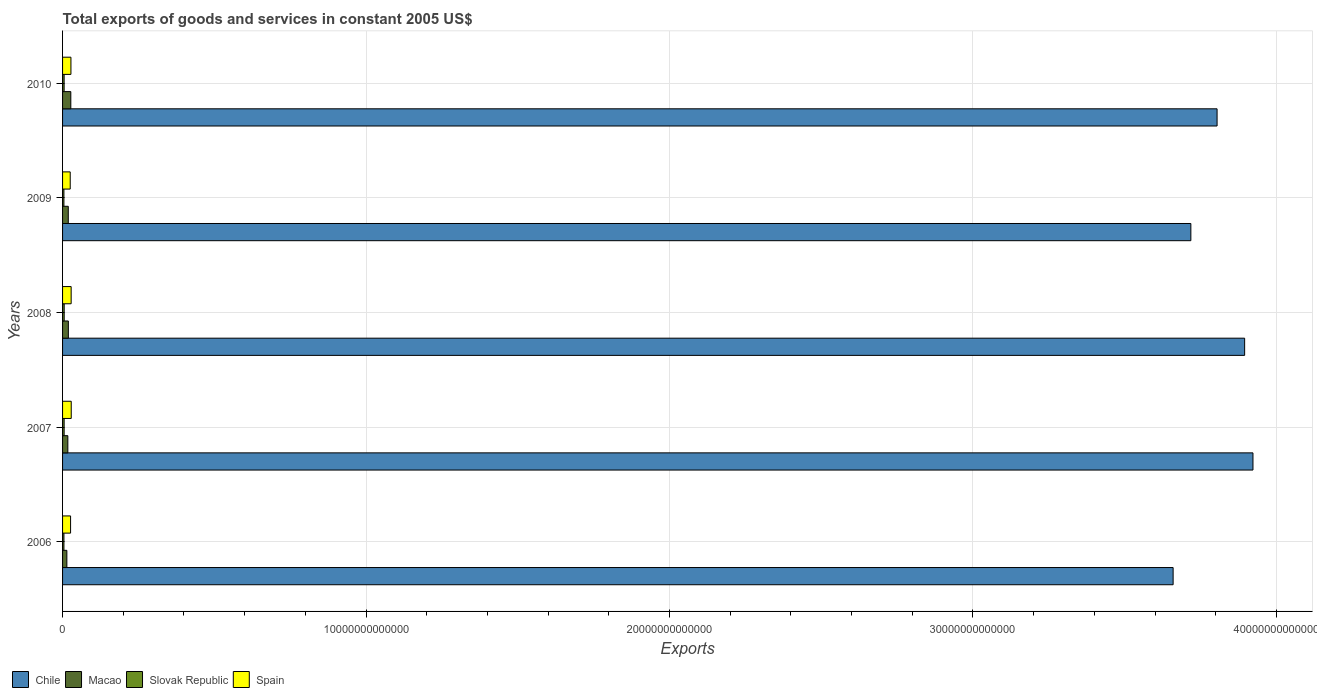How many different coloured bars are there?
Your answer should be very brief. 4. How many groups of bars are there?
Your answer should be very brief. 5. Are the number of bars on each tick of the Y-axis equal?
Give a very brief answer. Yes. What is the total exports of goods and services in Slovak Republic in 2010?
Provide a short and direct response. 5.16e+1. Across all years, what is the maximum total exports of goods and services in Spain?
Provide a short and direct response. 2.86e+11. Across all years, what is the minimum total exports of goods and services in Slovak Republic?
Provide a succinct answer. 4.46e+1. In which year was the total exports of goods and services in Chile maximum?
Offer a very short reply. 2007. What is the total total exports of goods and services in Macao in the graph?
Your answer should be compact. 9.66e+11. What is the difference between the total exports of goods and services in Chile in 2007 and that in 2010?
Keep it short and to the point. 1.18e+12. What is the difference between the total exports of goods and services in Spain in 2010 and the total exports of goods and services in Chile in 2009?
Offer a very short reply. -3.69e+13. What is the average total exports of goods and services in Macao per year?
Your answer should be compact. 1.93e+11. In the year 2010, what is the difference between the total exports of goods and services in Chile and total exports of goods and services in Macao?
Your answer should be compact. 3.78e+13. What is the ratio of the total exports of goods and services in Spain in 2008 to that in 2010?
Ensure brevity in your answer.  1.03. Is the total exports of goods and services in Chile in 2008 less than that in 2009?
Your answer should be compact. No. Is the difference between the total exports of goods and services in Chile in 2009 and 2010 greater than the difference between the total exports of goods and services in Macao in 2009 and 2010?
Your response must be concise. No. What is the difference between the highest and the second highest total exports of goods and services in Spain?
Provide a short and direct response. 2.42e+09. What is the difference between the highest and the lowest total exports of goods and services in Spain?
Your answer should be very brief. 3.37e+1. Is the sum of the total exports of goods and services in Chile in 2006 and 2008 greater than the maximum total exports of goods and services in Spain across all years?
Your answer should be compact. Yes. Is it the case that in every year, the sum of the total exports of goods and services in Chile and total exports of goods and services in Slovak Republic is greater than the sum of total exports of goods and services in Macao and total exports of goods and services in Spain?
Ensure brevity in your answer.  Yes. What does the 2nd bar from the top in 2006 represents?
Ensure brevity in your answer.  Slovak Republic. What does the 4th bar from the bottom in 2009 represents?
Give a very brief answer. Spain. Are all the bars in the graph horizontal?
Provide a succinct answer. Yes. How many years are there in the graph?
Provide a succinct answer. 5. What is the difference between two consecutive major ticks on the X-axis?
Provide a short and direct response. 1.00e+13. Does the graph contain any zero values?
Provide a succinct answer. No. How are the legend labels stacked?
Your answer should be very brief. Horizontal. What is the title of the graph?
Ensure brevity in your answer.  Total exports of goods and services in constant 2005 US$. What is the label or title of the X-axis?
Keep it short and to the point. Exports. What is the label or title of the Y-axis?
Offer a very short reply. Years. What is the Exports of Chile in 2006?
Offer a very short reply. 3.66e+13. What is the Exports of Macao in 2006?
Ensure brevity in your answer.  1.41e+11. What is the Exports of Slovak Republic in 2006?
Your answer should be compact. 4.54e+1. What is the Exports of Spain in 2006?
Your answer should be very brief. 2.64e+11. What is the Exports of Chile in 2007?
Provide a short and direct response. 3.92e+13. What is the Exports of Macao in 2007?
Provide a succinct answer. 1.74e+11. What is the Exports in Slovak Republic in 2007?
Your answer should be compact. 5.20e+1. What is the Exports in Spain in 2007?
Your answer should be compact. 2.86e+11. What is the Exports of Chile in 2008?
Your response must be concise. 3.90e+13. What is the Exports of Macao in 2008?
Offer a very short reply. 1.91e+11. What is the Exports of Slovak Republic in 2008?
Ensure brevity in your answer.  5.35e+1. What is the Exports in Spain in 2008?
Your answer should be very brief. 2.83e+11. What is the Exports of Chile in 2009?
Make the answer very short. 3.72e+13. What is the Exports of Macao in 2009?
Your answer should be compact. 1.88e+11. What is the Exports in Slovak Republic in 2009?
Provide a short and direct response. 4.46e+1. What is the Exports of Spain in 2009?
Keep it short and to the point. 2.52e+11. What is the Exports in Chile in 2010?
Give a very brief answer. 3.80e+13. What is the Exports of Macao in 2010?
Offer a terse response. 2.72e+11. What is the Exports of Slovak Republic in 2010?
Your answer should be very brief. 5.16e+1. What is the Exports in Spain in 2010?
Your answer should be very brief. 2.76e+11. Across all years, what is the maximum Exports in Chile?
Ensure brevity in your answer.  3.92e+13. Across all years, what is the maximum Exports in Macao?
Offer a very short reply. 2.72e+11. Across all years, what is the maximum Exports of Slovak Republic?
Provide a succinct answer. 5.35e+1. Across all years, what is the maximum Exports of Spain?
Ensure brevity in your answer.  2.86e+11. Across all years, what is the minimum Exports of Chile?
Provide a succinct answer. 3.66e+13. Across all years, what is the minimum Exports of Macao?
Give a very brief answer. 1.41e+11. Across all years, what is the minimum Exports of Slovak Republic?
Make the answer very short. 4.46e+1. Across all years, what is the minimum Exports in Spain?
Your response must be concise. 2.52e+11. What is the total Exports of Chile in the graph?
Ensure brevity in your answer.  1.90e+14. What is the total Exports of Macao in the graph?
Offer a terse response. 9.66e+11. What is the total Exports of Slovak Republic in the graph?
Make the answer very short. 2.47e+11. What is the total Exports in Spain in the graph?
Your answer should be compact. 1.36e+12. What is the difference between the Exports of Chile in 2006 and that in 2007?
Your response must be concise. -2.63e+12. What is the difference between the Exports in Macao in 2006 and that in 2007?
Your response must be concise. -3.27e+1. What is the difference between the Exports in Slovak Republic in 2006 and that in 2007?
Your response must be concise. -6.62e+09. What is the difference between the Exports of Spain in 2006 and that in 2007?
Ensure brevity in your answer.  -2.18e+1. What is the difference between the Exports of Chile in 2006 and that in 2008?
Provide a short and direct response. -2.36e+12. What is the difference between the Exports of Macao in 2006 and that in 2008?
Give a very brief answer. -4.92e+1. What is the difference between the Exports in Slovak Republic in 2006 and that in 2008?
Your response must be concise. -8.19e+09. What is the difference between the Exports in Spain in 2006 and that in 2008?
Give a very brief answer. -1.94e+1. What is the difference between the Exports of Chile in 2006 and that in 2009?
Make the answer very short. -5.84e+11. What is the difference between the Exports of Macao in 2006 and that in 2009?
Offer a terse response. -4.67e+1. What is the difference between the Exports of Slovak Republic in 2006 and that in 2009?
Make the answer very short. 7.84e+08. What is the difference between the Exports in Spain in 2006 and that in 2009?
Your answer should be very brief. 1.19e+1. What is the difference between the Exports of Chile in 2006 and that in 2010?
Provide a short and direct response. -1.45e+12. What is the difference between the Exports of Macao in 2006 and that in 2010?
Provide a short and direct response. -1.30e+11. What is the difference between the Exports in Slovak Republic in 2006 and that in 2010?
Keep it short and to the point. -6.23e+09. What is the difference between the Exports in Spain in 2006 and that in 2010?
Offer a terse response. -1.19e+1. What is the difference between the Exports in Chile in 2007 and that in 2008?
Keep it short and to the point. 2.75e+11. What is the difference between the Exports in Macao in 2007 and that in 2008?
Provide a succinct answer. -1.65e+1. What is the difference between the Exports of Slovak Republic in 2007 and that in 2008?
Your answer should be very brief. -1.57e+09. What is the difference between the Exports of Spain in 2007 and that in 2008?
Offer a terse response. 2.42e+09. What is the difference between the Exports in Chile in 2007 and that in 2009?
Your answer should be very brief. 2.05e+12. What is the difference between the Exports of Macao in 2007 and that in 2009?
Ensure brevity in your answer.  -1.40e+1. What is the difference between the Exports in Slovak Republic in 2007 and that in 2009?
Offer a terse response. 7.41e+09. What is the difference between the Exports in Spain in 2007 and that in 2009?
Provide a succinct answer. 3.37e+1. What is the difference between the Exports of Chile in 2007 and that in 2010?
Keep it short and to the point. 1.18e+12. What is the difference between the Exports in Macao in 2007 and that in 2010?
Your answer should be compact. -9.77e+1. What is the difference between the Exports in Slovak Republic in 2007 and that in 2010?
Your answer should be very brief. 3.94e+08. What is the difference between the Exports in Spain in 2007 and that in 2010?
Offer a terse response. 9.90e+09. What is the difference between the Exports of Chile in 2008 and that in 2009?
Your answer should be compact. 1.77e+12. What is the difference between the Exports in Macao in 2008 and that in 2009?
Offer a terse response. 2.52e+09. What is the difference between the Exports in Slovak Republic in 2008 and that in 2009?
Give a very brief answer. 8.98e+09. What is the difference between the Exports in Spain in 2008 and that in 2009?
Offer a terse response. 3.12e+1. What is the difference between the Exports of Chile in 2008 and that in 2010?
Your answer should be compact. 9.08e+11. What is the difference between the Exports in Macao in 2008 and that in 2010?
Provide a succinct answer. -8.12e+1. What is the difference between the Exports of Slovak Republic in 2008 and that in 2010?
Give a very brief answer. 1.96e+09. What is the difference between the Exports in Spain in 2008 and that in 2010?
Make the answer very short. 7.47e+09. What is the difference between the Exports in Chile in 2009 and that in 2010?
Your answer should be compact. -8.64e+11. What is the difference between the Exports of Macao in 2009 and that in 2010?
Make the answer very short. -8.37e+1. What is the difference between the Exports in Slovak Republic in 2009 and that in 2010?
Keep it short and to the point. -7.01e+09. What is the difference between the Exports in Spain in 2009 and that in 2010?
Provide a short and direct response. -2.38e+1. What is the difference between the Exports of Chile in 2006 and the Exports of Macao in 2007?
Offer a very short reply. 3.64e+13. What is the difference between the Exports of Chile in 2006 and the Exports of Slovak Republic in 2007?
Your answer should be very brief. 3.65e+13. What is the difference between the Exports of Chile in 2006 and the Exports of Spain in 2007?
Make the answer very short. 3.63e+13. What is the difference between the Exports in Macao in 2006 and the Exports in Slovak Republic in 2007?
Your answer should be compact. 8.95e+1. What is the difference between the Exports in Macao in 2006 and the Exports in Spain in 2007?
Offer a terse response. -1.44e+11. What is the difference between the Exports of Slovak Republic in 2006 and the Exports of Spain in 2007?
Your answer should be compact. -2.40e+11. What is the difference between the Exports of Chile in 2006 and the Exports of Macao in 2008?
Keep it short and to the point. 3.64e+13. What is the difference between the Exports in Chile in 2006 and the Exports in Slovak Republic in 2008?
Offer a very short reply. 3.65e+13. What is the difference between the Exports in Chile in 2006 and the Exports in Spain in 2008?
Ensure brevity in your answer.  3.63e+13. What is the difference between the Exports in Macao in 2006 and the Exports in Slovak Republic in 2008?
Keep it short and to the point. 8.79e+1. What is the difference between the Exports in Macao in 2006 and the Exports in Spain in 2008?
Make the answer very short. -1.42e+11. What is the difference between the Exports in Slovak Republic in 2006 and the Exports in Spain in 2008?
Provide a short and direct response. -2.38e+11. What is the difference between the Exports in Chile in 2006 and the Exports in Macao in 2009?
Offer a terse response. 3.64e+13. What is the difference between the Exports of Chile in 2006 and the Exports of Slovak Republic in 2009?
Ensure brevity in your answer.  3.66e+13. What is the difference between the Exports in Chile in 2006 and the Exports in Spain in 2009?
Give a very brief answer. 3.63e+13. What is the difference between the Exports of Macao in 2006 and the Exports of Slovak Republic in 2009?
Your response must be concise. 9.69e+1. What is the difference between the Exports in Macao in 2006 and the Exports in Spain in 2009?
Ensure brevity in your answer.  -1.11e+11. What is the difference between the Exports of Slovak Republic in 2006 and the Exports of Spain in 2009?
Make the answer very short. -2.07e+11. What is the difference between the Exports of Chile in 2006 and the Exports of Macao in 2010?
Your answer should be very brief. 3.63e+13. What is the difference between the Exports in Chile in 2006 and the Exports in Slovak Republic in 2010?
Give a very brief answer. 3.65e+13. What is the difference between the Exports of Chile in 2006 and the Exports of Spain in 2010?
Give a very brief answer. 3.63e+13. What is the difference between the Exports of Macao in 2006 and the Exports of Slovak Republic in 2010?
Give a very brief answer. 8.99e+1. What is the difference between the Exports of Macao in 2006 and the Exports of Spain in 2010?
Give a very brief answer. -1.34e+11. What is the difference between the Exports of Slovak Republic in 2006 and the Exports of Spain in 2010?
Ensure brevity in your answer.  -2.30e+11. What is the difference between the Exports in Chile in 2007 and the Exports in Macao in 2008?
Provide a short and direct response. 3.90e+13. What is the difference between the Exports of Chile in 2007 and the Exports of Slovak Republic in 2008?
Your answer should be very brief. 3.92e+13. What is the difference between the Exports of Chile in 2007 and the Exports of Spain in 2008?
Offer a very short reply. 3.89e+13. What is the difference between the Exports of Macao in 2007 and the Exports of Slovak Republic in 2008?
Provide a succinct answer. 1.21e+11. What is the difference between the Exports of Macao in 2007 and the Exports of Spain in 2008?
Offer a terse response. -1.09e+11. What is the difference between the Exports in Slovak Republic in 2007 and the Exports in Spain in 2008?
Give a very brief answer. -2.31e+11. What is the difference between the Exports of Chile in 2007 and the Exports of Macao in 2009?
Make the answer very short. 3.90e+13. What is the difference between the Exports of Chile in 2007 and the Exports of Slovak Republic in 2009?
Your answer should be very brief. 3.92e+13. What is the difference between the Exports of Chile in 2007 and the Exports of Spain in 2009?
Your response must be concise. 3.90e+13. What is the difference between the Exports of Macao in 2007 and the Exports of Slovak Republic in 2009?
Offer a very short reply. 1.30e+11. What is the difference between the Exports of Macao in 2007 and the Exports of Spain in 2009?
Provide a succinct answer. -7.79e+1. What is the difference between the Exports of Slovak Republic in 2007 and the Exports of Spain in 2009?
Provide a succinct answer. -2.00e+11. What is the difference between the Exports in Chile in 2007 and the Exports in Macao in 2010?
Your answer should be compact. 3.90e+13. What is the difference between the Exports in Chile in 2007 and the Exports in Slovak Republic in 2010?
Your answer should be very brief. 3.92e+13. What is the difference between the Exports of Chile in 2007 and the Exports of Spain in 2010?
Ensure brevity in your answer.  3.90e+13. What is the difference between the Exports in Macao in 2007 and the Exports in Slovak Republic in 2010?
Provide a short and direct response. 1.23e+11. What is the difference between the Exports of Macao in 2007 and the Exports of Spain in 2010?
Offer a terse response. -1.02e+11. What is the difference between the Exports of Slovak Republic in 2007 and the Exports of Spain in 2010?
Your answer should be very brief. -2.24e+11. What is the difference between the Exports in Chile in 2008 and the Exports in Macao in 2009?
Your answer should be compact. 3.88e+13. What is the difference between the Exports of Chile in 2008 and the Exports of Slovak Republic in 2009?
Your answer should be very brief. 3.89e+13. What is the difference between the Exports in Chile in 2008 and the Exports in Spain in 2009?
Your answer should be compact. 3.87e+13. What is the difference between the Exports in Macao in 2008 and the Exports in Slovak Republic in 2009?
Offer a very short reply. 1.46e+11. What is the difference between the Exports in Macao in 2008 and the Exports in Spain in 2009?
Your response must be concise. -6.14e+1. What is the difference between the Exports in Slovak Republic in 2008 and the Exports in Spain in 2009?
Offer a terse response. -1.99e+11. What is the difference between the Exports in Chile in 2008 and the Exports in Macao in 2010?
Your answer should be compact. 3.87e+13. What is the difference between the Exports in Chile in 2008 and the Exports in Slovak Republic in 2010?
Make the answer very short. 3.89e+13. What is the difference between the Exports in Chile in 2008 and the Exports in Spain in 2010?
Your answer should be very brief. 3.87e+13. What is the difference between the Exports of Macao in 2008 and the Exports of Slovak Republic in 2010?
Your response must be concise. 1.39e+11. What is the difference between the Exports in Macao in 2008 and the Exports in Spain in 2010?
Offer a very short reply. -8.52e+1. What is the difference between the Exports in Slovak Republic in 2008 and the Exports in Spain in 2010?
Your answer should be very brief. -2.22e+11. What is the difference between the Exports of Chile in 2009 and the Exports of Macao in 2010?
Offer a terse response. 3.69e+13. What is the difference between the Exports in Chile in 2009 and the Exports in Slovak Republic in 2010?
Give a very brief answer. 3.71e+13. What is the difference between the Exports of Chile in 2009 and the Exports of Spain in 2010?
Offer a very short reply. 3.69e+13. What is the difference between the Exports of Macao in 2009 and the Exports of Slovak Republic in 2010?
Make the answer very short. 1.37e+11. What is the difference between the Exports in Macao in 2009 and the Exports in Spain in 2010?
Your answer should be very brief. -8.77e+1. What is the difference between the Exports of Slovak Republic in 2009 and the Exports of Spain in 2010?
Provide a short and direct response. -2.31e+11. What is the average Exports in Chile per year?
Your response must be concise. 3.80e+13. What is the average Exports of Macao per year?
Provide a succinct answer. 1.93e+11. What is the average Exports of Slovak Republic per year?
Provide a succinct answer. 4.94e+1. What is the average Exports in Spain per year?
Keep it short and to the point. 2.72e+11. In the year 2006, what is the difference between the Exports of Chile and Exports of Macao?
Offer a terse response. 3.65e+13. In the year 2006, what is the difference between the Exports in Chile and Exports in Slovak Republic?
Keep it short and to the point. 3.66e+13. In the year 2006, what is the difference between the Exports of Chile and Exports of Spain?
Offer a terse response. 3.63e+13. In the year 2006, what is the difference between the Exports of Macao and Exports of Slovak Republic?
Your answer should be compact. 9.61e+1. In the year 2006, what is the difference between the Exports in Macao and Exports in Spain?
Offer a very short reply. -1.23e+11. In the year 2006, what is the difference between the Exports in Slovak Republic and Exports in Spain?
Your answer should be very brief. -2.19e+11. In the year 2007, what is the difference between the Exports of Chile and Exports of Macao?
Provide a succinct answer. 3.91e+13. In the year 2007, what is the difference between the Exports in Chile and Exports in Slovak Republic?
Offer a very short reply. 3.92e+13. In the year 2007, what is the difference between the Exports in Chile and Exports in Spain?
Keep it short and to the point. 3.89e+13. In the year 2007, what is the difference between the Exports of Macao and Exports of Slovak Republic?
Your answer should be compact. 1.22e+11. In the year 2007, what is the difference between the Exports in Macao and Exports in Spain?
Your answer should be very brief. -1.12e+11. In the year 2007, what is the difference between the Exports of Slovak Republic and Exports of Spain?
Offer a very short reply. -2.34e+11. In the year 2008, what is the difference between the Exports in Chile and Exports in Macao?
Keep it short and to the point. 3.88e+13. In the year 2008, what is the difference between the Exports in Chile and Exports in Slovak Republic?
Your answer should be very brief. 3.89e+13. In the year 2008, what is the difference between the Exports in Chile and Exports in Spain?
Give a very brief answer. 3.87e+13. In the year 2008, what is the difference between the Exports of Macao and Exports of Slovak Republic?
Offer a terse response. 1.37e+11. In the year 2008, what is the difference between the Exports in Macao and Exports in Spain?
Give a very brief answer. -9.26e+1. In the year 2008, what is the difference between the Exports in Slovak Republic and Exports in Spain?
Offer a very short reply. -2.30e+11. In the year 2009, what is the difference between the Exports of Chile and Exports of Macao?
Make the answer very short. 3.70e+13. In the year 2009, what is the difference between the Exports in Chile and Exports in Slovak Republic?
Provide a succinct answer. 3.71e+13. In the year 2009, what is the difference between the Exports in Chile and Exports in Spain?
Your answer should be compact. 3.69e+13. In the year 2009, what is the difference between the Exports in Macao and Exports in Slovak Republic?
Make the answer very short. 1.44e+11. In the year 2009, what is the difference between the Exports in Macao and Exports in Spain?
Make the answer very short. -6.39e+1. In the year 2009, what is the difference between the Exports in Slovak Republic and Exports in Spain?
Ensure brevity in your answer.  -2.08e+11. In the year 2010, what is the difference between the Exports in Chile and Exports in Macao?
Offer a very short reply. 3.78e+13. In the year 2010, what is the difference between the Exports in Chile and Exports in Slovak Republic?
Make the answer very short. 3.80e+13. In the year 2010, what is the difference between the Exports in Chile and Exports in Spain?
Give a very brief answer. 3.78e+13. In the year 2010, what is the difference between the Exports of Macao and Exports of Slovak Republic?
Offer a terse response. 2.20e+11. In the year 2010, what is the difference between the Exports in Macao and Exports in Spain?
Your answer should be very brief. -3.97e+09. In the year 2010, what is the difference between the Exports in Slovak Republic and Exports in Spain?
Offer a terse response. -2.24e+11. What is the ratio of the Exports of Chile in 2006 to that in 2007?
Offer a terse response. 0.93. What is the ratio of the Exports of Macao in 2006 to that in 2007?
Ensure brevity in your answer.  0.81. What is the ratio of the Exports in Slovak Republic in 2006 to that in 2007?
Make the answer very short. 0.87. What is the ratio of the Exports in Spain in 2006 to that in 2007?
Provide a short and direct response. 0.92. What is the ratio of the Exports of Chile in 2006 to that in 2008?
Keep it short and to the point. 0.94. What is the ratio of the Exports in Macao in 2006 to that in 2008?
Give a very brief answer. 0.74. What is the ratio of the Exports of Slovak Republic in 2006 to that in 2008?
Provide a short and direct response. 0.85. What is the ratio of the Exports in Spain in 2006 to that in 2008?
Make the answer very short. 0.93. What is the ratio of the Exports of Chile in 2006 to that in 2009?
Your answer should be very brief. 0.98. What is the ratio of the Exports of Macao in 2006 to that in 2009?
Offer a very short reply. 0.75. What is the ratio of the Exports in Slovak Republic in 2006 to that in 2009?
Offer a terse response. 1.02. What is the ratio of the Exports of Spain in 2006 to that in 2009?
Give a very brief answer. 1.05. What is the ratio of the Exports of Chile in 2006 to that in 2010?
Keep it short and to the point. 0.96. What is the ratio of the Exports in Macao in 2006 to that in 2010?
Keep it short and to the point. 0.52. What is the ratio of the Exports in Slovak Republic in 2006 to that in 2010?
Make the answer very short. 0.88. What is the ratio of the Exports in Spain in 2006 to that in 2010?
Provide a succinct answer. 0.96. What is the ratio of the Exports of Chile in 2007 to that in 2008?
Provide a succinct answer. 1.01. What is the ratio of the Exports of Macao in 2007 to that in 2008?
Make the answer very short. 0.91. What is the ratio of the Exports of Slovak Republic in 2007 to that in 2008?
Provide a short and direct response. 0.97. What is the ratio of the Exports in Spain in 2007 to that in 2008?
Ensure brevity in your answer.  1.01. What is the ratio of the Exports in Chile in 2007 to that in 2009?
Make the answer very short. 1.06. What is the ratio of the Exports in Macao in 2007 to that in 2009?
Your response must be concise. 0.93. What is the ratio of the Exports in Slovak Republic in 2007 to that in 2009?
Provide a succinct answer. 1.17. What is the ratio of the Exports of Spain in 2007 to that in 2009?
Make the answer very short. 1.13. What is the ratio of the Exports in Chile in 2007 to that in 2010?
Provide a succinct answer. 1.03. What is the ratio of the Exports of Macao in 2007 to that in 2010?
Ensure brevity in your answer.  0.64. What is the ratio of the Exports of Slovak Republic in 2007 to that in 2010?
Ensure brevity in your answer.  1.01. What is the ratio of the Exports of Spain in 2007 to that in 2010?
Your answer should be very brief. 1.04. What is the ratio of the Exports in Chile in 2008 to that in 2009?
Provide a short and direct response. 1.05. What is the ratio of the Exports in Macao in 2008 to that in 2009?
Provide a succinct answer. 1.01. What is the ratio of the Exports of Slovak Republic in 2008 to that in 2009?
Make the answer very short. 1.2. What is the ratio of the Exports in Spain in 2008 to that in 2009?
Offer a terse response. 1.12. What is the ratio of the Exports in Chile in 2008 to that in 2010?
Give a very brief answer. 1.02. What is the ratio of the Exports in Macao in 2008 to that in 2010?
Your answer should be very brief. 0.7. What is the ratio of the Exports of Slovak Republic in 2008 to that in 2010?
Ensure brevity in your answer.  1.04. What is the ratio of the Exports in Spain in 2008 to that in 2010?
Offer a very short reply. 1.03. What is the ratio of the Exports in Chile in 2009 to that in 2010?
Your response must be concise. 0.98. What is the ratio of the Exports in Macao in 2009 to that in 2010?
Provide a succinct answer. 0.69. What is the ratio of the Exports of Slovak Republic in 2009 to that in 2010?
Keep it short and to the point. 0.86. What is the ratio of the Exports in Spain in 2009 to that in 2010?
Offer a very short reply. 0.91. What is the difference between the highest and the second highest Exports in Chile?
Your answer should be very brief. 2.75e+11. What is the difference between the highest and the second highest Exports in Macao?
Give a very brief answer. 8.12e+1. What is the difference between the highest and the second highest Exports of Slovak Republic?
Provide a short and direct response. 1.57e+09. What is the difference between the highest and the second highest Exports of Spain?
Make the answer very short. 2.42e+09. What is the difference between the highest and the lowest Exports in Chile?
Give a very brief answer. 2.63e+12. What is the difference between the highest and the lowest Exports of Macao?
Keep it short and to the point. 1.30e+11. What is the difference between the highest and the lowest Exports in Slovak Republic?
Offer a terse response. 8.98e+09. What is the difference between the highest and the lowest Exports in Spain?
Your answer should be compact. 3.37e+1. 